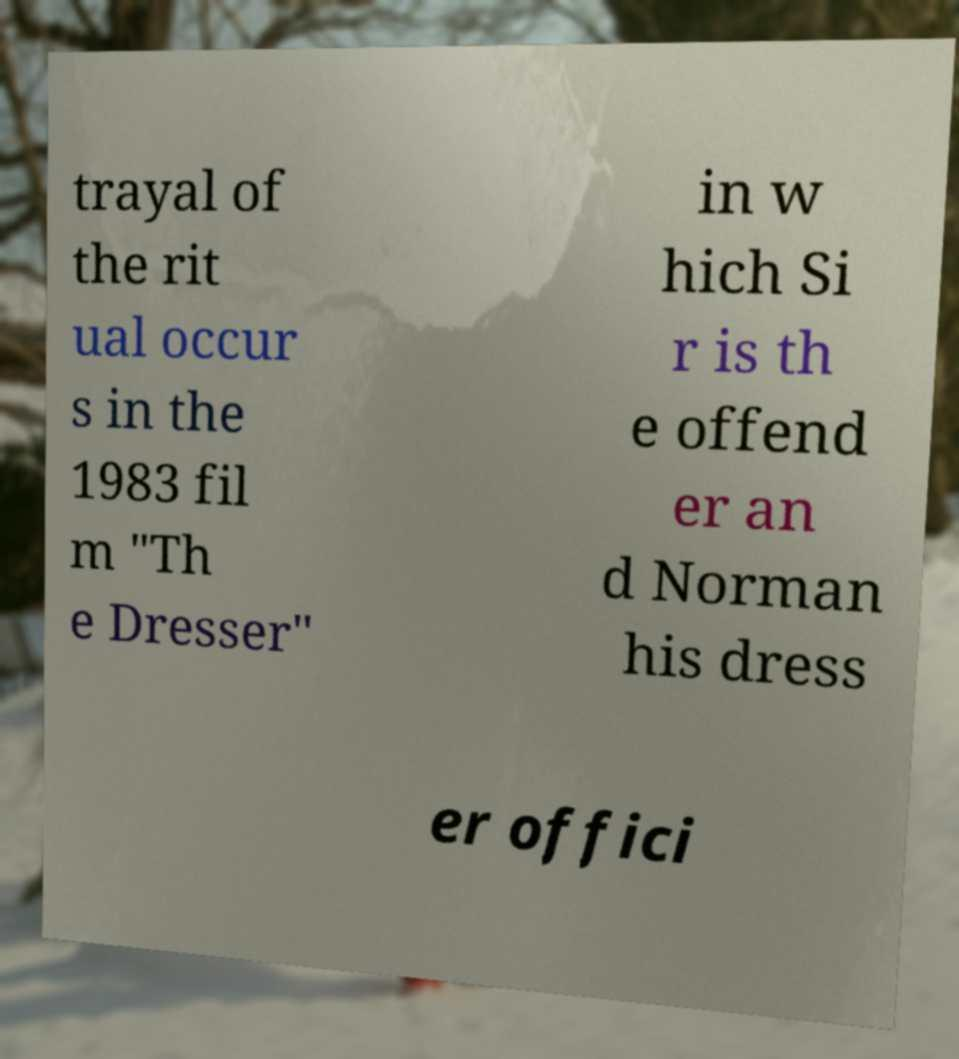For documentation purposes, I need the text within this image transcribed. Could you provide that? trayal of the rit ual occur s in the 1983 fil m "Th e Dresser" in w hich Si r is th e offend er an d Norman his dress er offici 